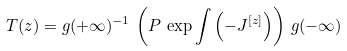Convert formula to latex. <formula><loc_0><loc_0><loc_500><loc_500>T ( z ) = g ( + \infty ) ^ { - 1 } \, \left ( P \, \exp \int \left ( - J ^ { [ z ] } \right ) \right ) \, g ( - \infty )</formula> 